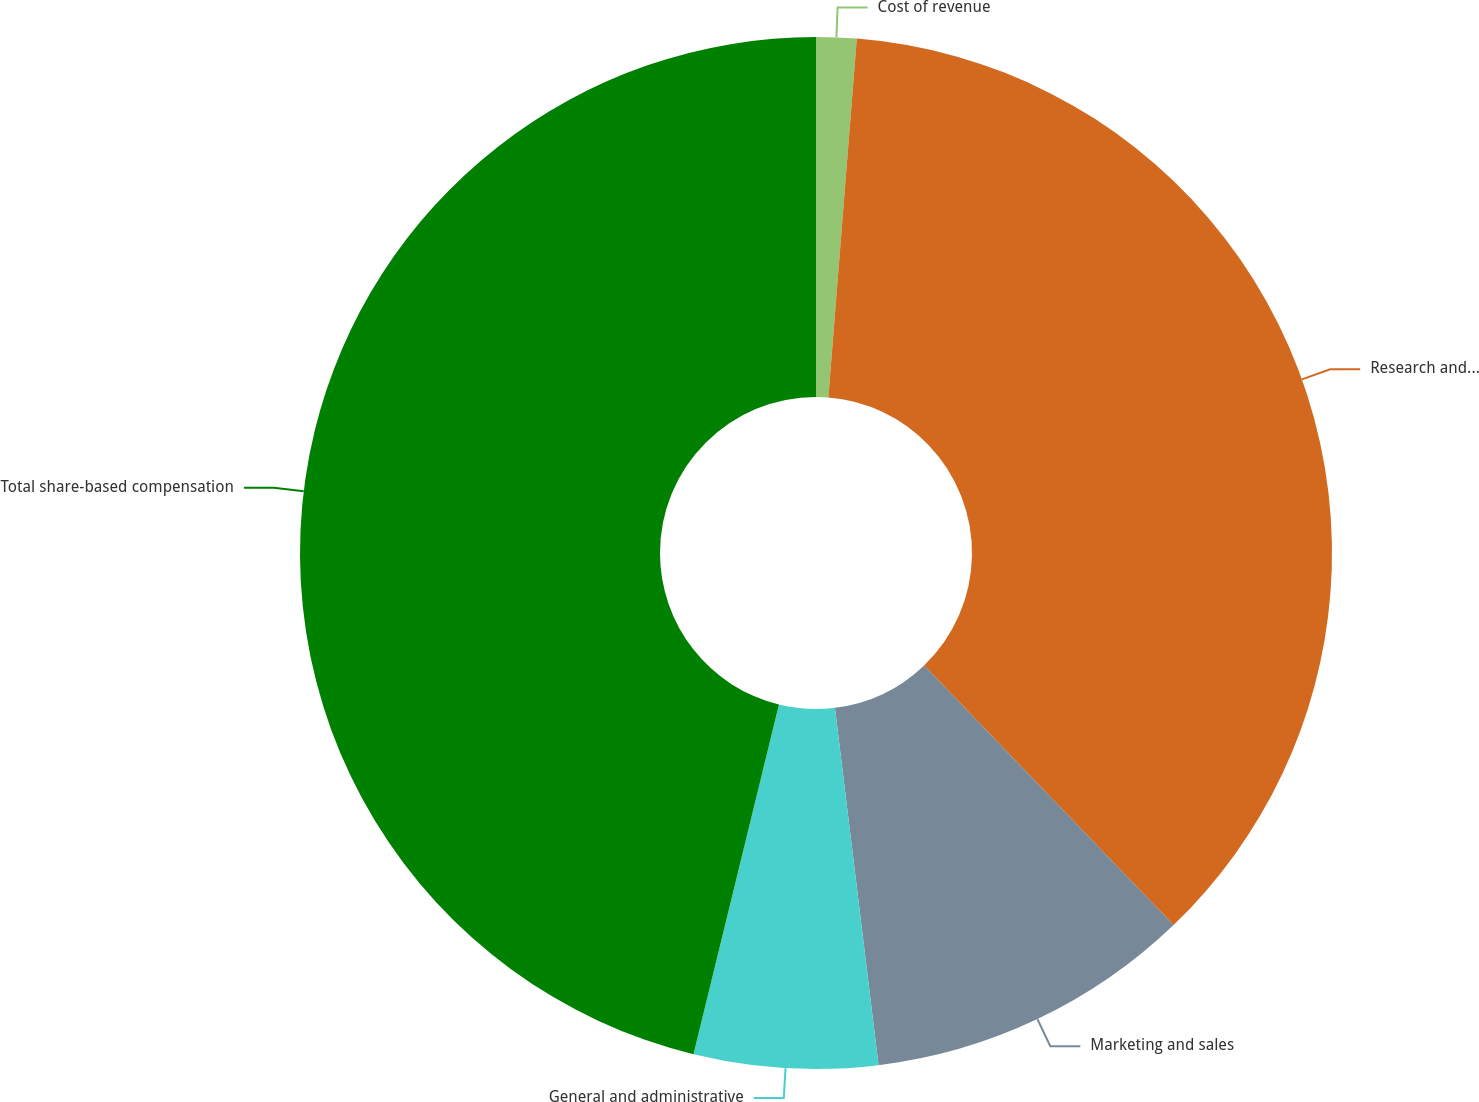Convert chart to OTSL. <chart><loc_0><loc_0><loc_500><loc_500><pie_chart><fcel>Cost of revenue<fcel>Research and development<fcel>Marketing and sales<fcel>General and administrative<fcel>Total share-based compensation<nl><fcel>1.26%<fcel>36.56%<fcel>10.25%<fcel>5.75%<fcel>46.19%<nl></chart> 